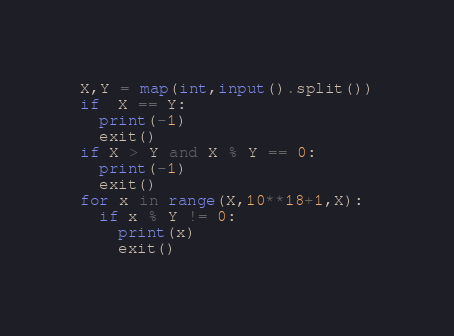<code> <loc_0><loc_0><loc_500><loc_500><_Python_>X,Y = map(int,input().split())
if  X == Y:
  print(-1)
  exit()
if X > Y and X % Y == 0:
  print(-1)
  exit()
for x in range(X,10**18+1,X):
  if x % Y != 0:
    print(x)
    exit()</code> 